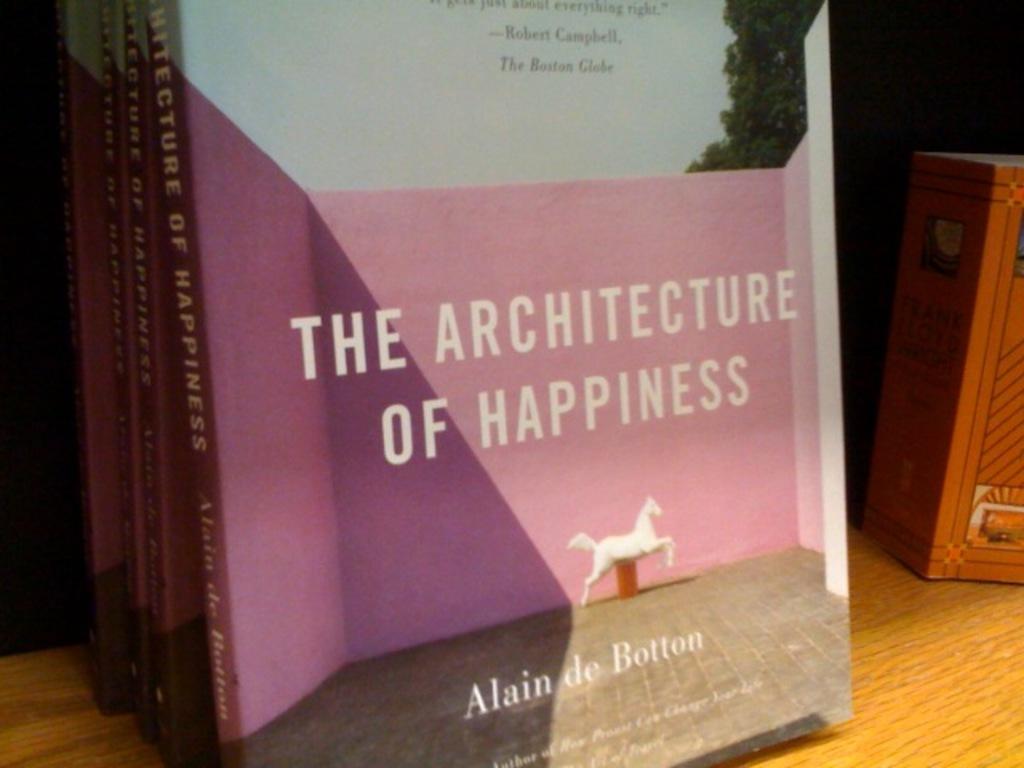What is the book title?
Offer a very short reply. The architecture of happiness. 